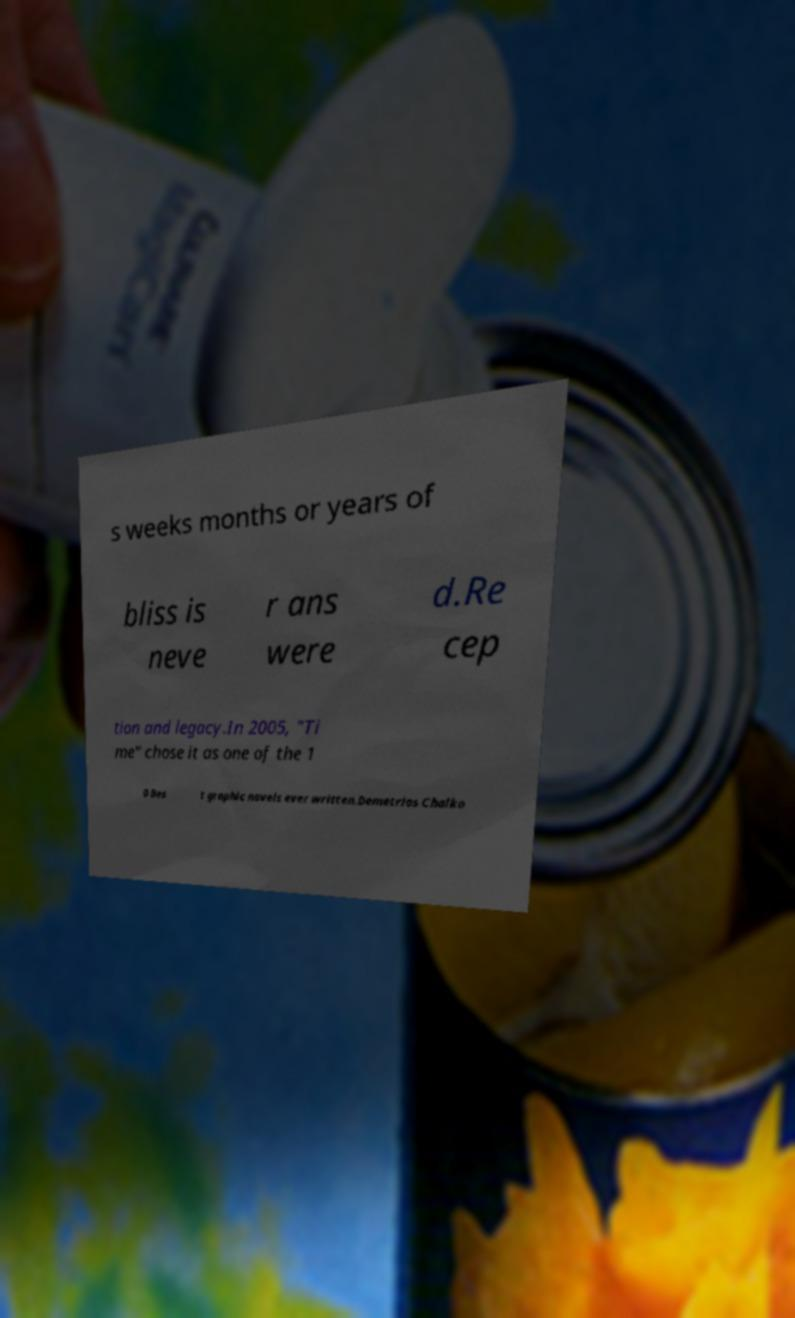Could you extract and type out the text from this image? s weeks months or years of bliss is neve r ans were d.Re cep tion and legacy.In 2005, "Ti me" chose it as one of the 1 0 Bes t graphic novels ever written.Demetrios Chalko 